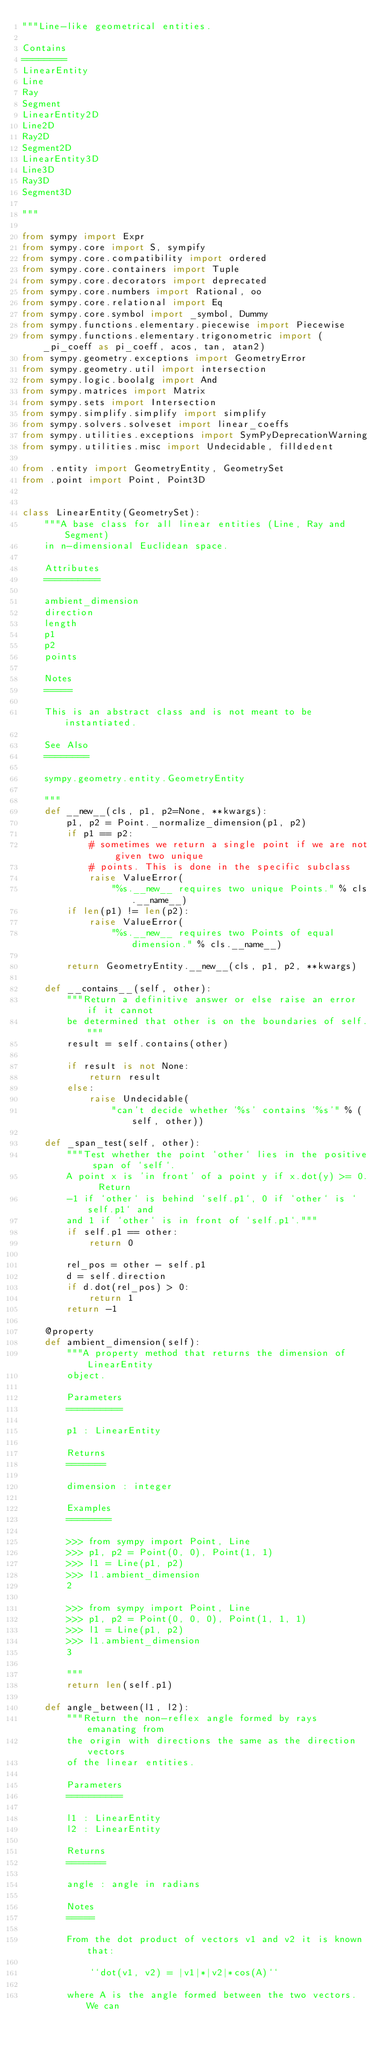<code> <loc_0><loc_0><loc_500><loc_500><_Python_>"""Line-like geometrical entities.

Contains
========
LinearEntity
Line
Ray
Segment
LinearEntity2D
Line2D
Ray2D
Segment2D
LinearEntity3D
Line3D
Ray3D
Segment3D

"""

from sympy import Expr
from sympy.core import S, sympify
from sympy.core.compatibility import ordered
from sympy.core.containers import Tuple
from sympy.core.decorators import deprecated
from sympy.core.numbers import Rational, oo
from sympy.core.relational import Eq
from sympy.core.symbol import _symbol, Dummy
from sympy.functions.elementary.piecewise import Piecewise
from sympy.functions.elementary.trigonometric import (_pi_coeff as pi_coeff, acos, tan, atan2)
from sympy.geometry.exceptions import GeometryError
from sympy.geometry.util import intersection
from sympy.logic.boolalg import And
from sympy.matrices import Matrix
from sympy.sets import Intersection
from sympy.simplify.simplify import simplify
from sympy.solvers.solveset import linear_coeffs
from sympy.utilities.exceptions import SymPyDeprecationWarning
from sympy.utilities.misc import Undecidable, filldedent

from .entity import GeometryEntity, GeometrySet
from .point import Point, Point3D


class LinearEntity(GeometrySet):
    """A base class for all linear entities (Line, Ray and Segment)
    in n-dimensional Euclidean space.

    Attributes
    ==========

    ambient_dimension
    direction
    length
    p1
    p2
    points

    Notes
    =====

    This is an abstract class and is not meant to be instantiated.

    See Also
    ========

    sympy.geometry.entity.GeometryEntity

    """
    def __new__(cls, p1, p2=None, **kwargs):
        p1, p2 = Point._normalize_dimension(p1, p2)
        if p1 == p2:
            # sometimes we return a single point if we are not given two unique
            # points. This is done in the specific subclass
            raise ValueError(
                "%s.__new__ requires two unique Points." % cls.__name__)
        if len(p1) != len(p2):
            raise ValueError(
                "%s.__new__ requires two Points of equal dimension." % cls.__name__)

        return GeometryEntity.__new__(cls, p1, p2, **kwargs)

    def __contains__(self, other):
        """Return a definitive answer or else raise an error if it cannot
        be determined that other is on the boundaries of self."""
        result = self.contains(other)

        if result is not None:
            return result
        else:
            raise Undecidable(
                "can't decide whether '%s' contains '%s'" % (self, other))

    def _span_test(self, other):
        """Test whether the point `other` lies in the positive span of `self`.
        A point x is 'in front' of a point y if x.dot(y) >= 0.  Return
        -1 if `other` is behind `self.p1`, 0 if `other` is `self.p1` and
        and 1 if `other` is in front of `self.p1`."""
        if self.p1 == other:
            return 0

        rel_pos = other - self.p1
        d = self.direction
        if d.dot(rel_pos) > 0:
            return 1
        return -1

    @property
    def ambient_dimension(self):
        """A property method that returns the dimension of LinearEntity
        object.

        Parameters
        ==========

        p1 : LinearEntity

        Returns
        =======

        dimension : integer

        Examples
        ========

        >>> from sympy import Point, Line
        >>> p1, p2 = Point(0, 0), Point(1, 1)
        >>> l1 = Line(p1, p2)
        >>> l1.ambient_dimension
        2

        >>> from sympy import Point, Line
        >>> p1, p2 = Point(0, 0, 0), Point(1, 1, 1)
        >>> l1 = Line(p1, p2)
        >>> l1.ambient_dimension
        3

        """
        return len(self.p1)

    def angle_between(l1, l2):
        """Return the non-reflex angle formed by rays emanating from
        the origin with directions the same as the direction vectors
        of the linear entities.

        Parameters
        ==========

        l1 : LinearEntity
        l2 : LinearEntity

        Returns
        =======

        angle : angle in radians

        Notes
        =====

        From the dot product of vectors v1 and v2 it is known that:

            ``dot(v1, v2) = |v1|*|v2|*cos(A)``

        where A is the angle formed between the two vectors. We can</code> 